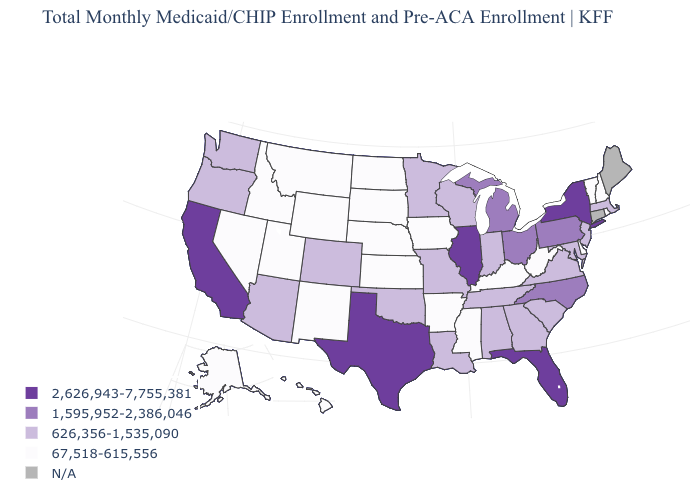What is the highest value in the USA?
Short answer required. 2,626,943-7,755,381. How many symbols are there in the legend?
Write a very short answer. 5. Name the states that have a value in the range 2,626,943-7,755,381?
Write a very short answer. California, Florida, Illinois, New York, Texas. Name the states that have a value in the range 67,518-615,556?
Be succinct. Alaska, Arkansas, Delaware, Hawaii, Idaho, Iowa, Kansas, Kentucky, Mississippi, Montana, Nebraska, Nevada, New Hampshire, New Mexico, North Dakota, Rhode Island, South Dakota, Utah, Vermont, West Virginia, Wyoming. What is the value of New Jersey?
Short answer required. 626,356-1,535,090. Name the states that have a value in the range N/A?
Keep it brief. Connecticut, Maine. Name the states that have a value in the range 1,595,952-2,386,046?
Keep it brief. Michigan, North Carolina, Ohio, Pennsylvania. Which states have the lowest value in the West?
Answer briefly. Alaska, Hawaii, Idaho, Montana, Nevada, New Mexico, Utah, Wyoming. Which states have the highest value in the USA?
Concise answer only. California, Florida, Illinois, New York, Texas. What is the value of Rhode Island?
Short answer required. 67,518-615,556. What is the value of Georgia?
Give a very brief answer. 626,356-1,535,090. Name the states that have a value in the range N/A?
Give a very brief answer. Connecticut, Maine. Which states have the lowest value in the USA?
Quick response, please. Alaska, Arkansas, Delaware, Hawaii, Idaho, Iowa, Kansas, Kentucky, Mississippi, Montana, Nebraska, Nevada, New Hampshire, New Mexico, North Dakota, Rhode Island, South Dakota, Utah, Vermont, West Virginia, Wyoming. Name the states that have a value in the range 626,356-1,535,090?
Write a very short answer. Alabama, Arizona, Colorado, Georgia, Indiana, Louisiana, Maryland, Massachusetts, Minnesota, Missouri, New Jersey, Oklahoma, Oregon, South Carolina, Tennessee, Virginia, Washington, Wisconsin. Which states have the highest value in the USA?
Be succinct. California, Florida, Illinois, New York, Texas. 